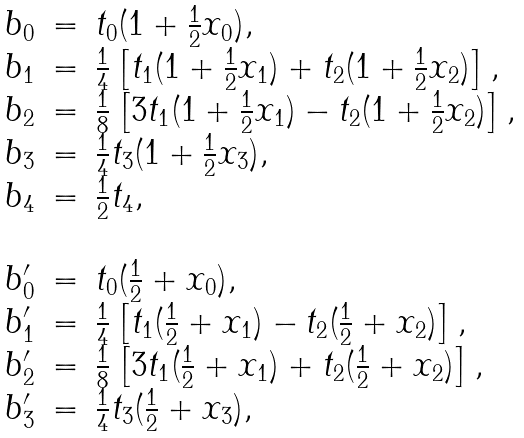<formula> <loc_0><loc_0><loc_500><loc_500>\begin{array} { r c l } b _ { 0 } & = & t _ { 0 } ( 1 + \frac { 1 } { 2 } x _ { 0 } ) , \\ b _ { 1 } & = & \frac { 1 } { 4 } \left [ t _ { 1 } ( 1 + \frac { 1 } { 2 } x _ { 1 } ) + t _ { 2 } ( 1 + \frac { 1 } { 2 } x _ { 2 } ) \right ] , \\ b _ { 2 } & = & \frac { 1 } { 8 } \left [ 3 t _ { 1 } ( 1 + \frac { 1 } { 2 } x _ { 1 } ) - t _ { 2 } ( 1 + \frac { 1 } { 2 } x _ { 2 } ) \right ] , \\ b _ { 3 } & = & \frac { 1 } { 4 } t _ { 3 } ( 1 + \frac { 1 } { 2 } x _ { 3 } ) , \\ b _ { 4 } & = & \frac { 1 } { 2 } t _ { 4 } , \\ & & \\ b ^ { \prime } _ { 0 } & = & t _ { 0 } ( \frac { 1 } { 2 } + x _ { 0 } ) , \\ b ^ { \prime } _ { 1 } & = & \frac { 1 } { 4 } \left [ t _ { 1 } ( \frac { 1 } { 2 } + x _ { 1 } ) - t _ { 2 } ( \frac { 1 } { 2 } + x _ { 2 } ) \right ] , \\ b ^ { \prime } _ { 2 } & = & \frac { 1 } { 8 } \left [ 3 t _ { 1 } ( \frac { 1 } { 2 } + x _ { 1 } ) + t _ { 2 } ( \frac { 1 } { 2 } + x _ { 2 } ) \right ] , \\ b ^ { \prime } _ { 3 } & = & \frac { 1 } { 4 } t _ { 3 } ( \frac { 1 } { 2 } + x _ { 3 } ) , \\ \end{array}</formula> 